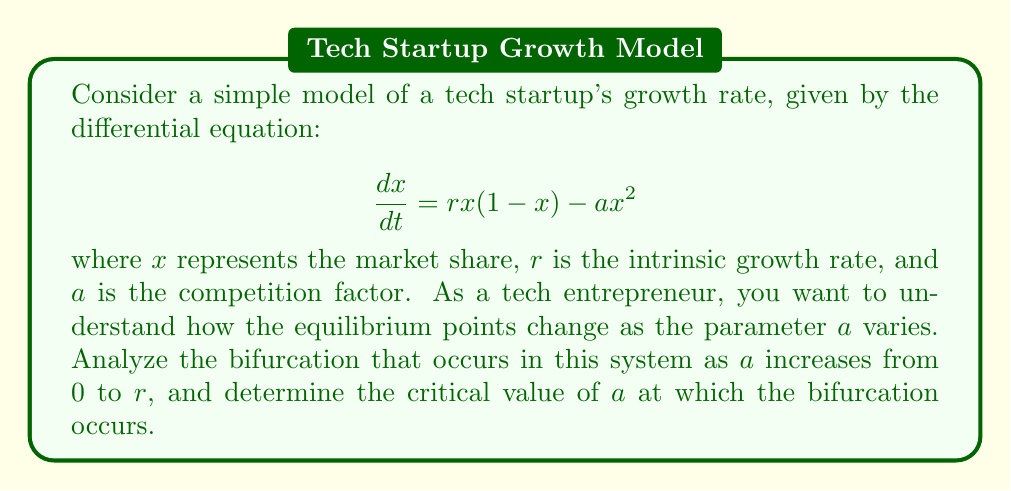Give your solution to this math problem. 1) First, let's find the equilibrium points by setting $\frac{dx}{dt} = 0$:

   $$rx(1-x) - ax^2 = 0$$
   $$x(r-rx-ax) = 0$$

2) We can factor this to get:
   $$x(r-(r+a)x) = 0$$

3) The equilibrium points are:
   $$x_1 = 0 \text{ and } x_2 = \frac{r}{r+a}$$

4) Now, let's examine the stability of these equilibrium points:
   
   The derivative of the right-hand side with respect to $x$ is:
   $$\frac{d}{dx}(rx(1-x) - ax^2) = r(1-2x) - 2ax$$

5) At $x_1 = 0$, the derivative is $r$, which is always positive. This means $x_1$ is always unstable.

6) At $x_2 = \frac{r}{r+a}$, the derivative is:
   $$r(1-2(\frac{r}{r+a})) - 2a(\frac{r}{r+a}) = -r$$

   This is always negative, meaning $x_2$ is always stable when it exists.

7) The bifurcation occurs when $x_2$ becomes negative, i.e., when $\frac{r}{r+a} < 0$.

8) Since $r$ is positive (representing growth), this occurs when $r+a < 0$, or $a > r$.

9) Therefore, the critical value of $a$ at which the bifurcation occurs is $a = r$.

10) This is a transcritical bifurcation, where the stable equilibrium $x_2$ collides with the unstable equilibrium $x_1$ at $a = r$, and they exchange stability.
Answer: $a = r$ 